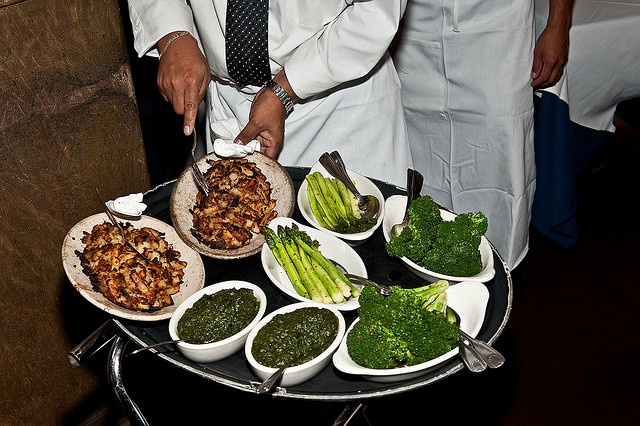Describe the objects in this image and their specific colors. I can see people in maroon, lightgray, darkgray, black, and brown tones, people in maroon, darkgray, gray, and black tones, bowl in maroon, black, ivory, and tan tones, broccoli in maroon, darkgreen, black, and olive tones, and bowl in maroon, ivory, olive, and black tones in this image. 